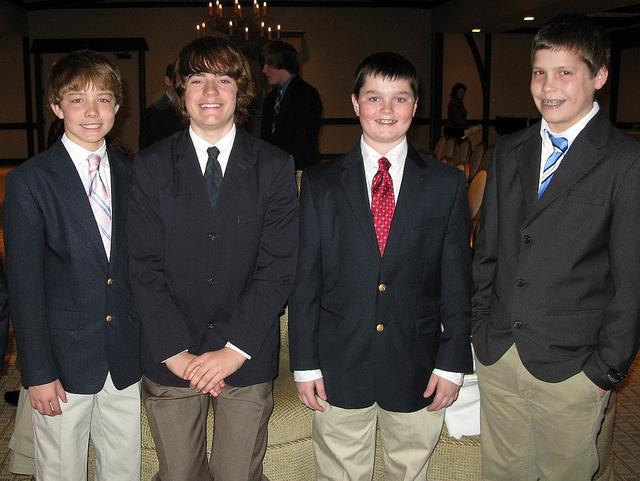Is this a casual event?
Be succinct. No. Are these adults?
Answer briefly. No. How many ties are there?
Answer briefly. 4. 